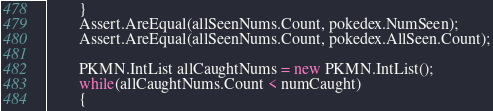<code> <loc_0><loc_0><loc_500><loc_500><_C#_>        }
        Assert.AreEqual(allSeenNums.Count, pokedex.NumSeen);
        Assert.AreEqual(allSeenNums.Count, pokedex.AllSeen.Count);

        PKMN.IntList allCaughtNums = new PKMN.IntList();
        while(allCaughtNums.Count < numCaught)
        {</code> 